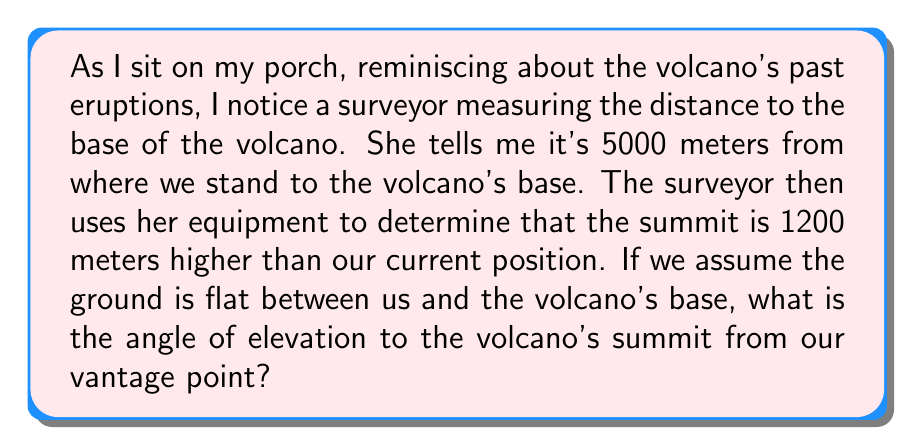What is the answer to this math problem? To solve this problem, we need to use trigonometry, specifically the tangent function. Let's break it down step-by-step:

1. Visualize the problem:
   [asy]
   import geometry;
   
   pair A = (0,0);
   pair B = (10,0);
   pair C = (10,2.4);
   
   draw(A--B--C--A);
   
   label("Our position", A, SW);
   label("Volcano base", B, SE);
   label("Summit", C, NE);
   label("5000 m", (A--B), S);
   label("1200 m", (B--C), E);
   label("$\theta$", A, NE);
   
   draw(A--(0,0.5)--(0.5,0.5)--(0.5,0), L="$\theta$");
   [/asy]

2. Identify the known values:
   - Adjacent side (distance to volcano base) = 5000 meters
   - Opposite side (height difference) = 1200 meters

3. Recall the tangent function:
   $$ \tan(\theta) = \frac{\text{opposite}}{\text{adjacent}} $$

4. Plug in the known values:
   $$ \tan(\theta) = \frac{1200}{5000} $$

5. Calculate the fraction:
   $$ \tan(\theta) = 0.24 $$

6. To find $\theta$, we need to use the inverse tangent (arctan) function:
   $$ \theta = \arctan(0.24) $$

7. Using a calculator or trigonometric tables:
   $$ \theta \approx 13.50° $$

Therefore, the angle of elevation to the volcano's summit from our position is approximately 13.50°.
Answer: $13.50°$ 